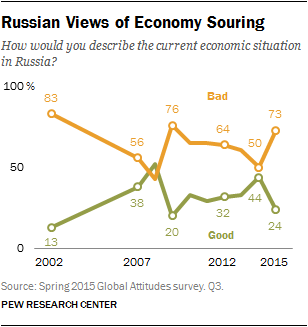List a handful of essential elements in this visual. The value of the Bad graph in 2007 was 56. The median of the first three points of the orange graph is not smaller than the largest value of the green graph. 